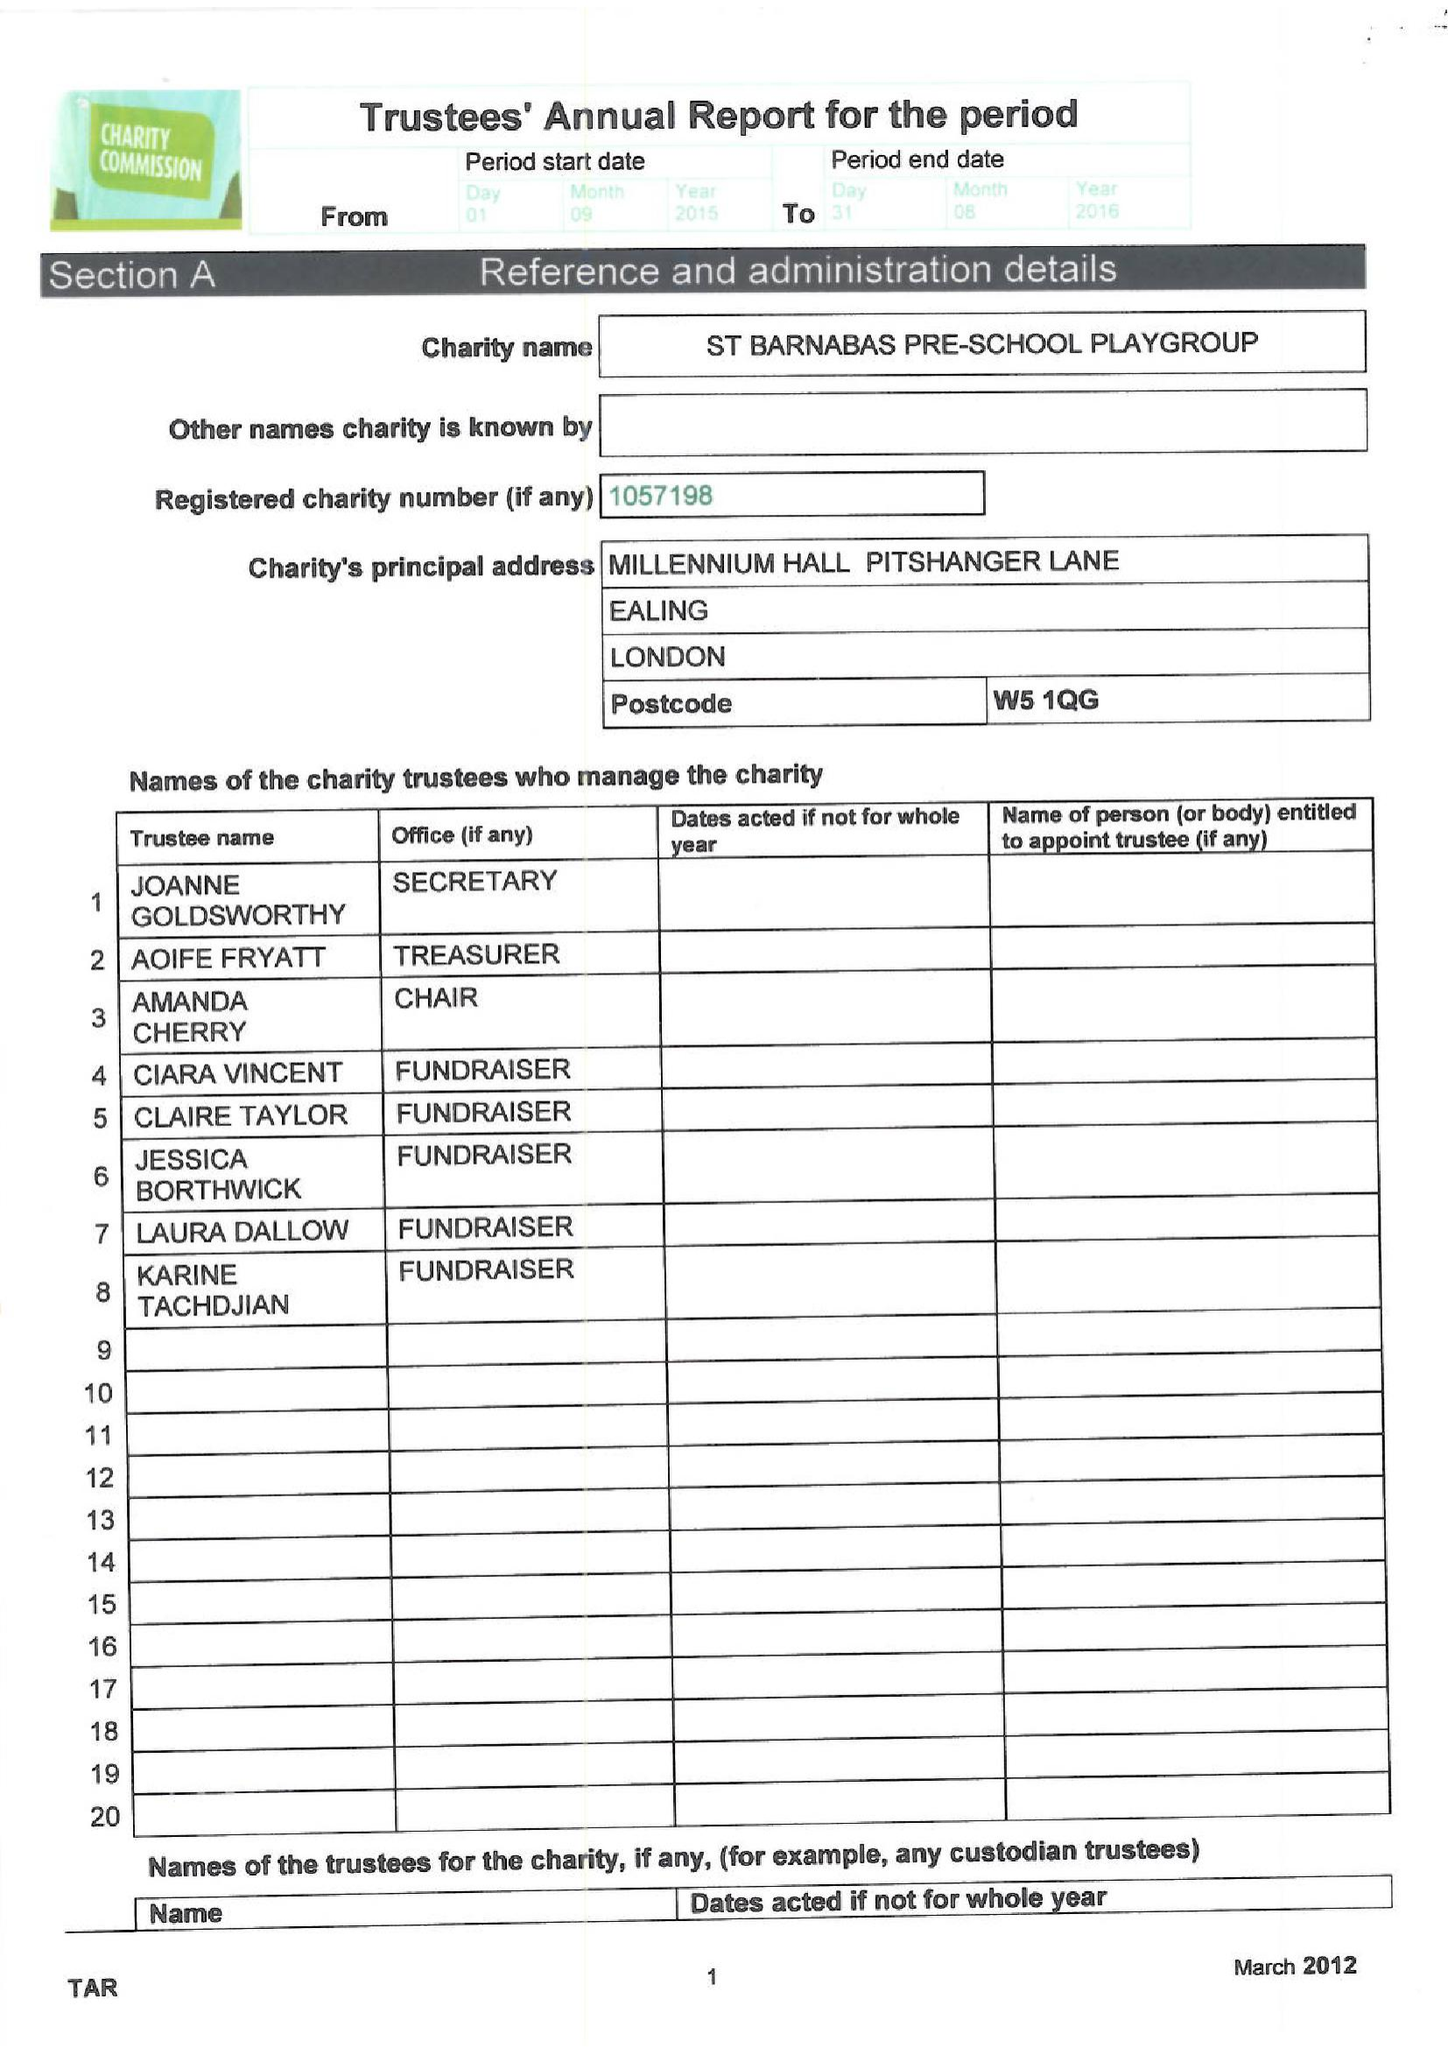What is the value for the report_date?
Answer the question using a single word or phrase. 2016-08-31 